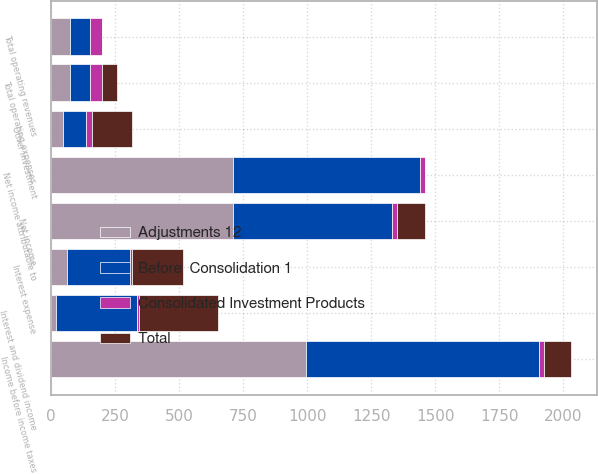<chart> <loc_0><loc_0><loc_500><loc_500><stacked_bar_chart><ecel><fcel>Total operating revenues<fcel>Total operating expenses<fcel>Interest and dividend income<fcel>Other investment<fcel>Interest expense<fcel>Income before income taxes<fcel>Net income<fcel>Net income attributable to<nl><fcel>Adjustments 12<fcel>75.85<fcel>75.85<fcel>19.3<fcel>49<fcel>61.8<fcel>995.5<fcel>709.4<fcel>709.5<nl><fcel>Total<fcel>0.1<fcel>60.3<fcel>307.2<fcel>159.2<fcel>195.3<fcel>107.5<fcel>107.5<fcel>0.1<nl><fcel>Consolidated Investment Products<fcel>47.3<fcel>47.3<fcel>8.3<fcel>20.3<fcel>8.3<fcel>20.1<fcel>20.1<fcel>20.1<nl><fcel>Before  Consolidation 1<fcel>75.85<fcel>75.85<fcel>318.2<fcel>89.9<fcel>248.8<fcel>908.1<fcel>622<fcel>729.7<nl></chart> 